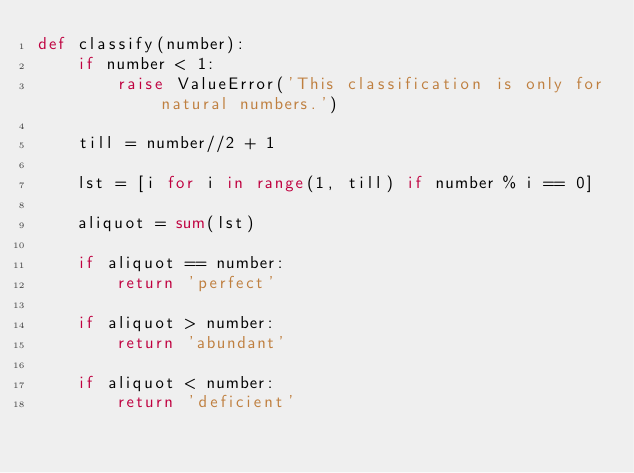<code> <loc_0><loc_0><loc_500><loc_500><_Python_>def classify(number):
    if number < 1:
        raise ValueError('This classification is only for natural numbers.')
    
    till = number//2 + 1

    lst = [i for i in range(1, till) if number % i == 0]
    
    aliquot = sum(lst)

    if aliquot == number:
        return 'perfect'

    if aliquot > number:
        return 'abundant'

    if aliquot < number:
        return 'deficient'
</code> 